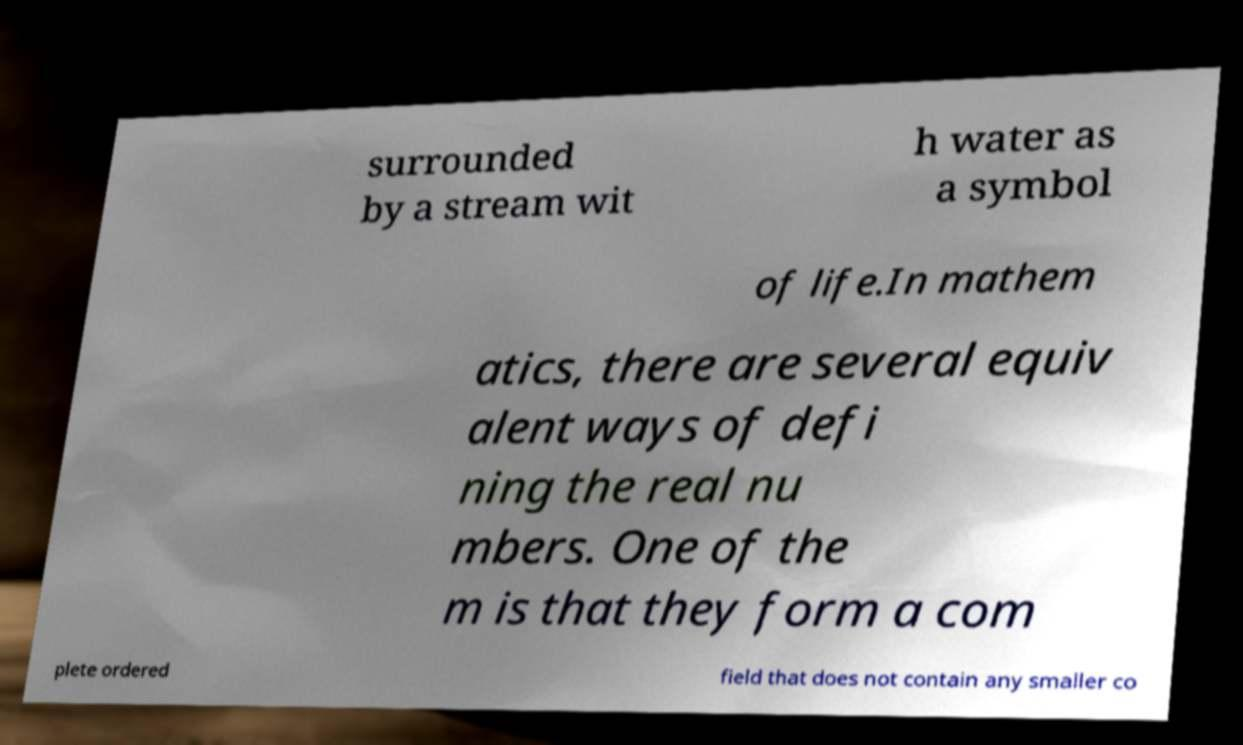Please identify and transcribe the text found in this image. surrounded by a stream wit h water as a symbol of life.In mathem atics, there are several equiv alent ways of defi ning the real nu mbers. One of the m is that they form a com plete ordered field that does not contain any smaller co 